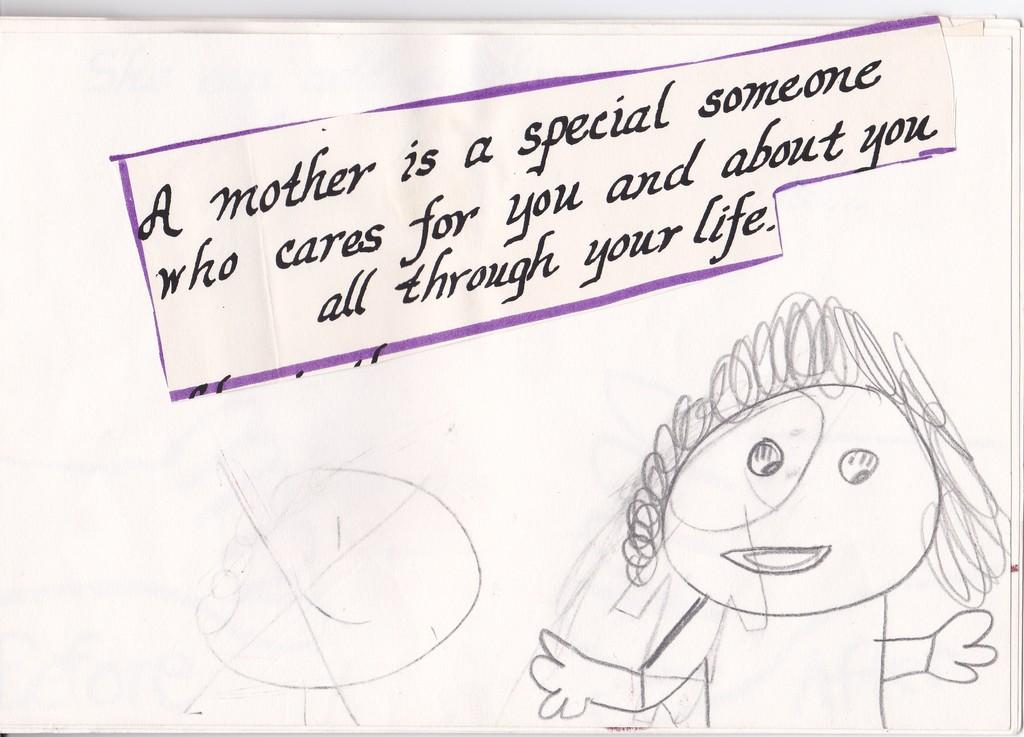What is depicted on the paper in the image? The paper contains a drawing. What else can be found on the paper besides the drawing? There is text written on the paper. How many tickets are visible in the image? There are no tickets present in the image. What type of boat is shown in the drawing on the paper? There is no boat depicted in the drawing on the paper. 